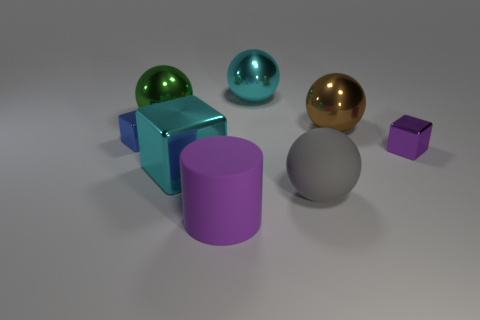Add 1 shiny spheres. How many objects exist? 9 Subtract all cubes. How many objects are left? 5 Add 2 spheres. How many spheres are left? 6 Add 1 large purple cubes. How many large purple cubes exist? 1 Subtract 0 purple balls. How many objects are left? 8 Subtract all shiny things. Subtract all purple rubber things. How many objects are left? 1 